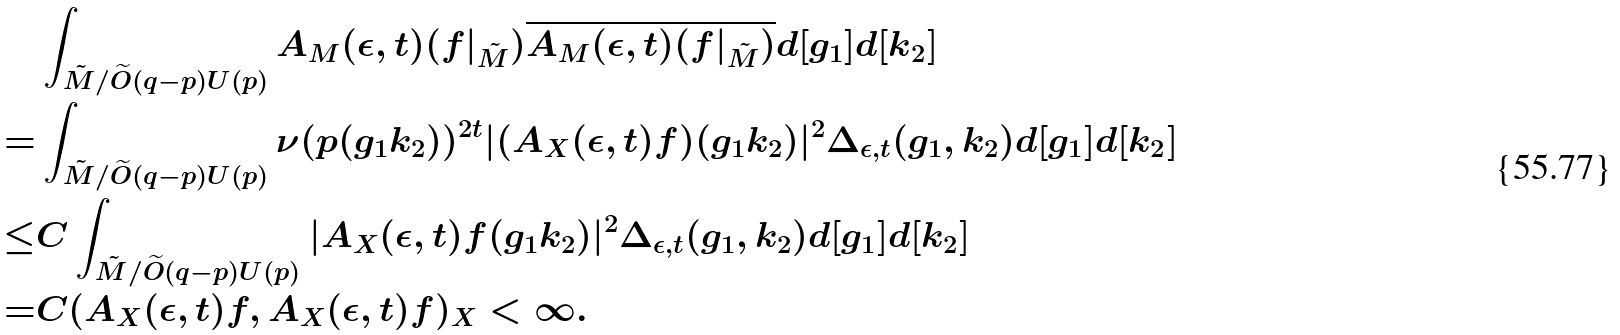Convert formula to latex. <formula><loc_0><loc_0><loc_500><loc_500>& \int _ { \tilde { M } / { \widetilde { O } ( q - p ) U ( p ) } } A _ { M } ( \epsilon , t ) ( f | _ { \tilde { M } } ) \overline { A _ { M } ( \epsilon , t ) ( f | _ { \tilde { M } } ) } d [ g _ { 1 } ] d [ k _ { 2 } ] \\ = & \int _ { \tilde { M } / { \widetilde { O } ( q - p ) U ( p ) } } \nu ( p ( g _ { 1 } k _ { 2 } ) ) ^ { 2 t } | ( A _ { X } ( \epsilon , t ) f ) ( g _ { 1 } k _ { 2 } ) | ^ { 2 } \Delta _ { \epsilon , t } ( g _ { 1 } , k _ { 2 } ) d [ g _ { 1 } ] d [ k _ { 2 } ] \\ \leq & C \int _ { \tilde { M } / { \widetilde { O } ( q - p ) U ( p ) } } | A _ { X } ( \epsilon , t ) f ( g _ { 1 } k _ { 2 } ) | ^ { 2 } \Delta _ { \epsilon , t } ( g _ { 1 } , k _ { 2 } ) d [ g _ { 1 } ] d [ k _ { 2 } ] \\ = & C ( A _ { X } ( \epsilon , t ) f , A _ { X } ( \epsilon , t ) f ) _ { X } < \infty .</formula> 